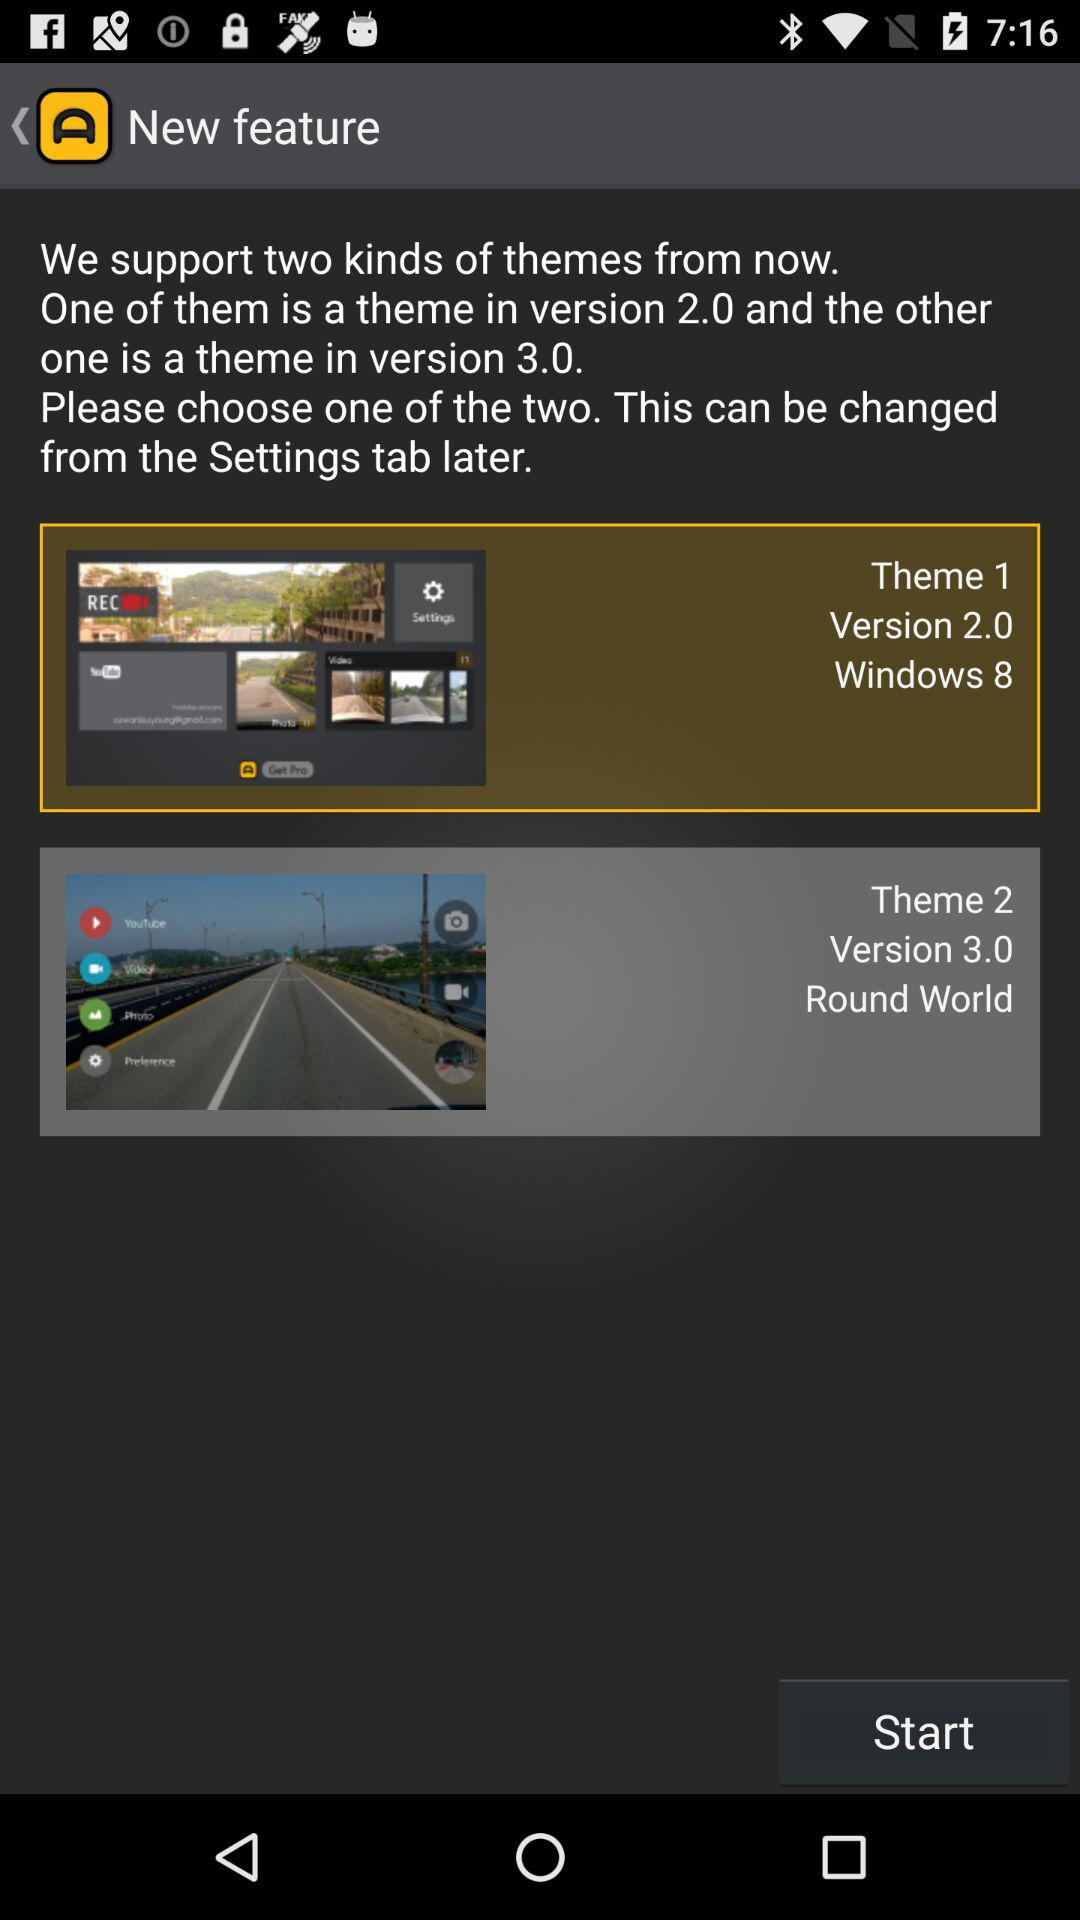How many themes are available in the app?
Answer the question using a single word or phrase. 2 